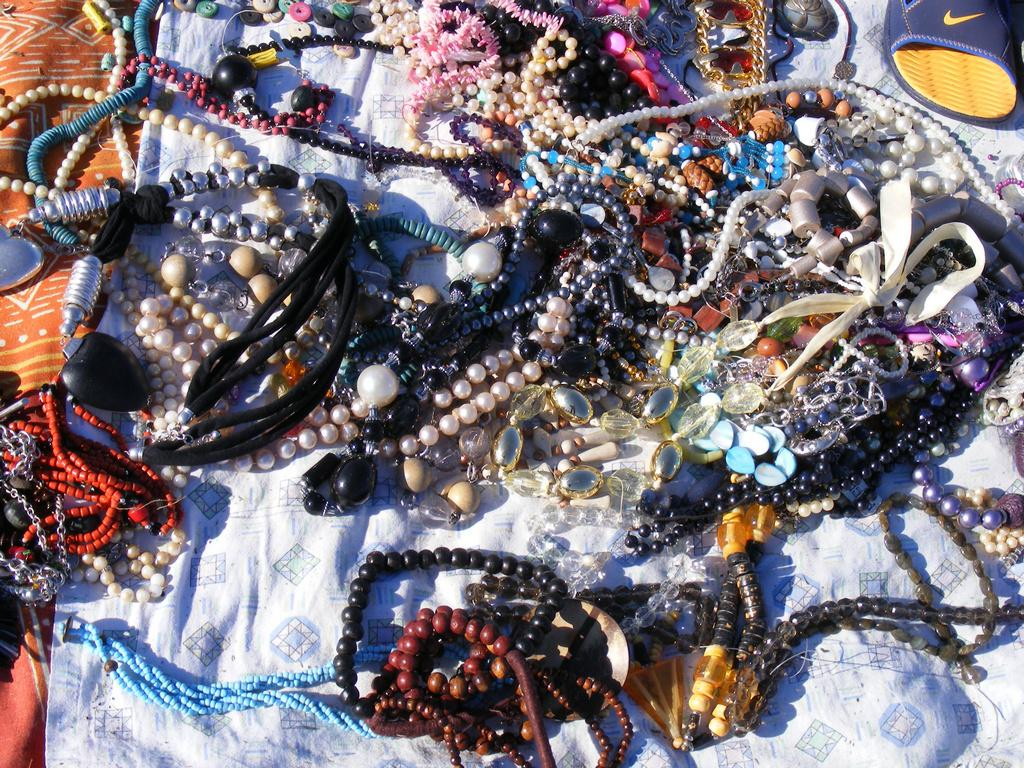What type of items can be seen in the image? There are colorful accessories in the image. What is the color of the cloth on which the accessories are placed? The cloth is white and brown in color. Where is the footwear located in the image? The footwear is visible to the right in the image. What type of sweater is being worn by the person in the image? There is no person visible in the image, so it is not possible to determine what type of sweater they might be wearing. 